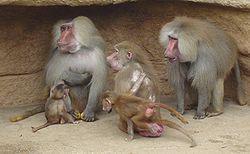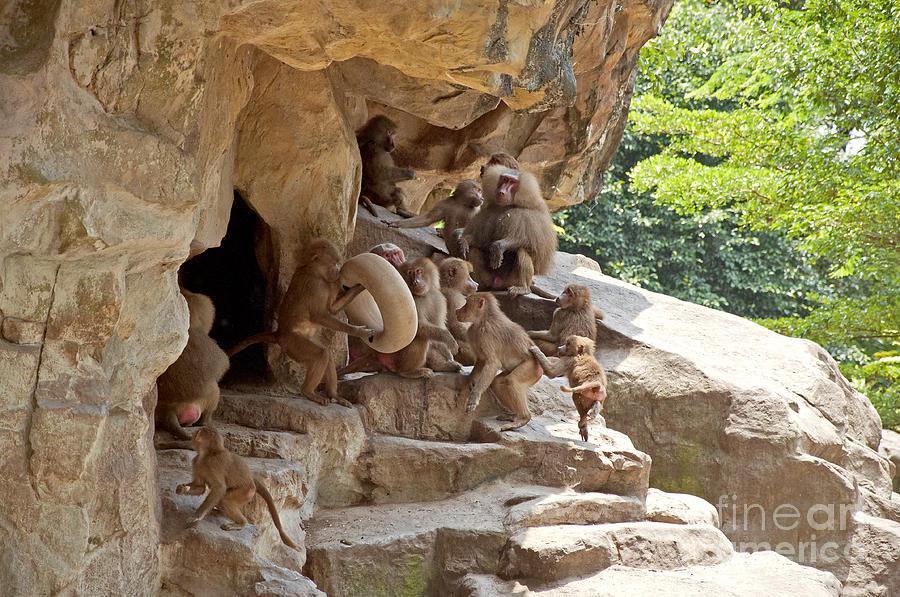The first image is the image on the left, the second image is the image on the right. Examine the images to the left and right. Is the description "Exactly two baboons are in the foreground in at least one image." accurate? Answer yes or no. No. 